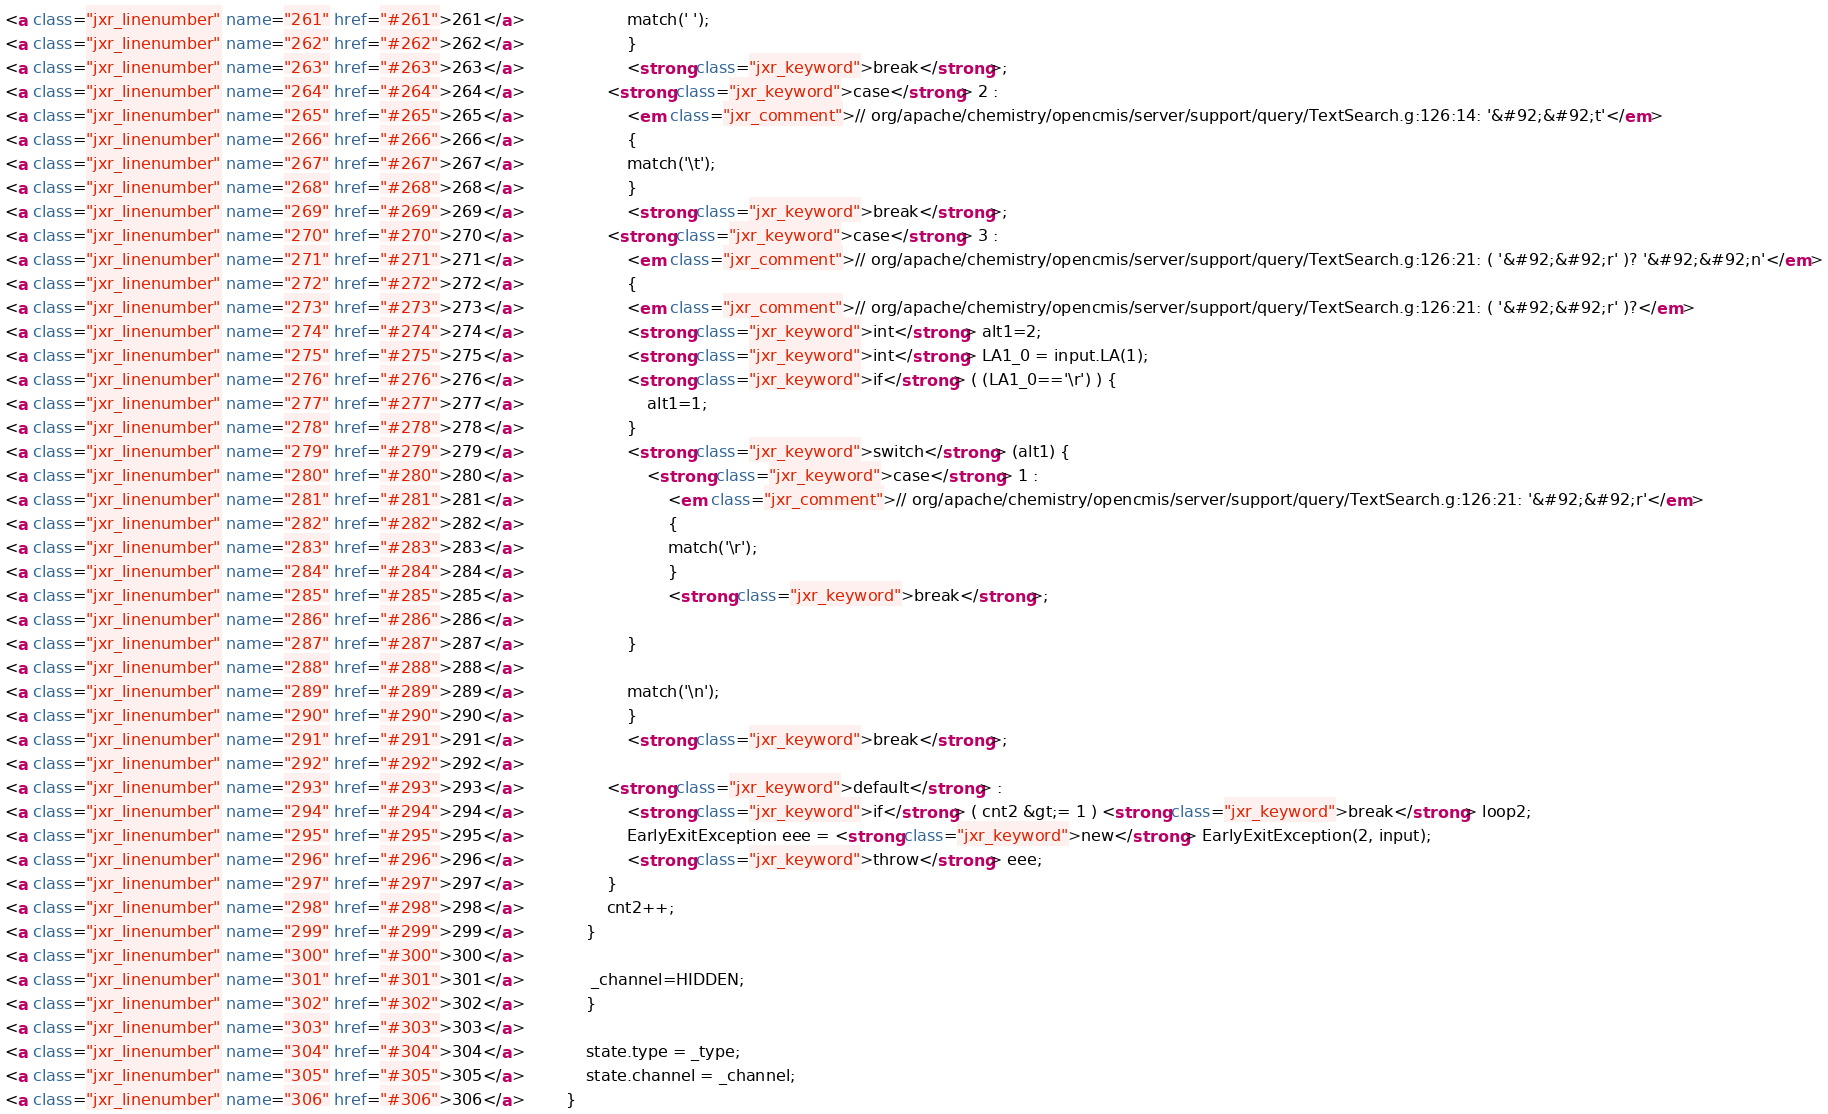Convert code to text. <code><loc_0><loc_0><loc_500><loc_500><_HTML_><a class="jxr_linenumber" name="261" href="#261">261</a> 					match(' '); 
<a class="jxr_linenumber" name="262" href="#262">262</a> 					}
<a class="jxr_linenumber" name="263" href="#263">263</a> 					<strong class="jxr_keyword">break</strong>;
<a class="jxr_linenumber" name="264" href="#264">264</a> 				<strong class="jxr_keyword">case</strong> 2 :
<a class="jxr_linenumber" name="265" href="#265">265</a> 					<em class="jxr_comment">// org/apache/chemistry/opencmis/server/support/query/TextSearch.g:126:14: '&#92;&#92;t'</em>
<a class="jxr_linenumber" name="266" href="#266">266</a> 					{
<a class="jxr_linenumber" name="267" href="#267">267</a> 					match('\t'); 
<a class="jxr_linenumber" name="268" href="#268">268</a> 					}
<a class="jxr_linenumber" name="269" href="#269">269</a> 					<strong class="jxr_keyword">break</strong>;
<a class="jxr_linenumber" name="270" href="#270">270</a> 				<strong class="jxr_keyword">case</strong> 3 :
<a class="jxr_linenumber" name="271" href="#271">271</a> 					<em class="jxr_comment">// org/apache/chemistry/opencmis/server/support/query/TextSearch.g:126:21: ( '&#92;&#92;r' )? '&#92;&#92;n'</em>
<a class="jxr_linenumber" name="272" href="#272">272</a> 					{
<a class="jxr_linenumber" name="273" href="#273">273</a> 					<em class="jxr_comment">// org/apache/chemistry/opencmis/server/support/query/TextSearch.g:126:21: ( '&#92;&#92;r' )?</em>
<a class="jxr_linenumber" name="274" href="#274">274</a> 					<strong class="jxr_keyword">int</strong> alt1=2;
<a class="jxr_linenumber" name="275" href="#275">275</a> 					<strong class="jxr_keyword">int</strong> LA1_0 = input.LA(1);
<a class="jxr_linenumber" name="276" href="#276">276</a> 					<strong class="jxr_keyword">if</strong> ( (LA1_0=='\r') ) {
<a class="jxr_linenumber" name="277" href="#277">277</a> 						alt1=1;
<a class="jxr_linenumber" name="278" href="#278">278</a> 					}
<a class="jxr_linenumber" name="279" href="#279">279</a> 					<strong class="jxr_keyword">switch</strong> (alt1) {
<a class="jxr_linenumber" name="280" href="#280">280</a> 						<strong class="jxr_keyword">case</strong> 1 :
<a class="jxr_linenumber" name="281" href="#281">281</a> 							<em class="jxr_comment">// org/apache/chemistry/opencmis/server/support/query/TextSearch.g:126:21: '&#92;&#92;r'</em>
<a class="jxr_linenumber" name="282" href="#282">282</a> 							{
<a class="jxr_linenumber" name="283" href="#283">283</a> 							match('\r'); 
<a class="jxr_linenumber" name="284" href="#284">284</a> 							}
<a class="jxr_linenumber" name="285" href="#285">285</a> 							<strong class="jxr_keyword">break</strong>;
<a class="jxr_linenumber" name="286" href="#286">286</a> 
<a class="jxr_linenumber" name="287" href="#287">287</a> 					}
<a class="jxr_linenumber" name="288" href="#288">288</a> 
<a class="jxr_linenumber" name="289" href="#289">289</a> 					match('\n'); 
<a class="jxr_linenumber" name="290" href="#290">290</a> 					}
<a class="jxr_linenumber" name="291" href="#291">291</a> 					<strong class="jxr_keyword">break</strong>;
<a class="jxr_linenumber" name="292" href="#292">292</a> 
<a class="jxr_linenumber" name="293" href="#293">293</a> 				<strong class="jxr_keyword">default</strong> :
<a class="jxr_linenumber" name="294" href="#294">294</a> 					<strong class="jxr_keyword">if</strong> ( cnt2 &gt;= 1 ) <strong class="jxr_keyword">break</strong> loop2;
<a class="jxr_linenumber" name="295" href="#295">295</a> 					EarlyExitException eee = <strong class="jxr_keyword">new</strong> EarlyExitException(2, input);
<a class="jxr_linenumber" name="296" href="#296">296</a> 					<strong class="jxr_keyword">throw</strong> eee;
<a class="jxr_linenumber" name="297" href="#297">297</a> 				}
<a class="jxr_linenumber" name="298" href="#298">298</a> 				cnt2++;
<a class="jxr_linenumber" name="299" href="#299">299</a> 			}
<a class="jxr_linenumber" name="300" href="#300">300</a> 
<a class="jxr_linenumber" name="301" href="#301">301</a> 			 _channel=HIDDEN; 
<a class="jxr_linenumber" name="302" href="#302">302</a> 			}
<a class="jxr_linenumber" name="303" href="#303">303</a> 
<a class="jxr_linenumber" name="304" href="#304">304</a> 			state.type = _type;
<a class="jxr_linenumber" name="305" href="#305">305</a> 			state.channel = _channel;
<a class="jxr_linenumber" name="306" href="#306">306</a> 		}</code> 